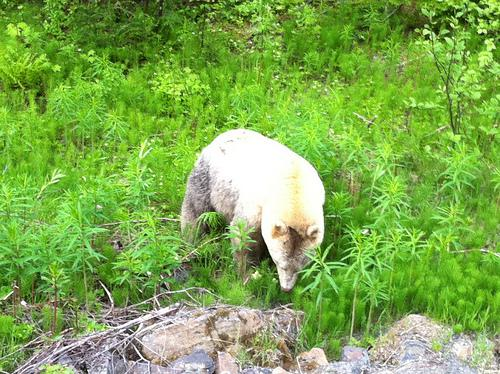Question: what is present?
Choices:
A. An animal.
B. A lady.
C. A man.
D. Two kids.
Answer with the letter. Answer: A Question: who is present?
Choices:
A. 1 person.
B. 2 people.
C. Several teens.
D. Nobody.
Answer with the letter. Answer: D Question: where was this photo taken?
Choices:
A. In the house.
B. In the woods.
C. In the shop.
D. In the store.
Answer with the letter. Answer: B 